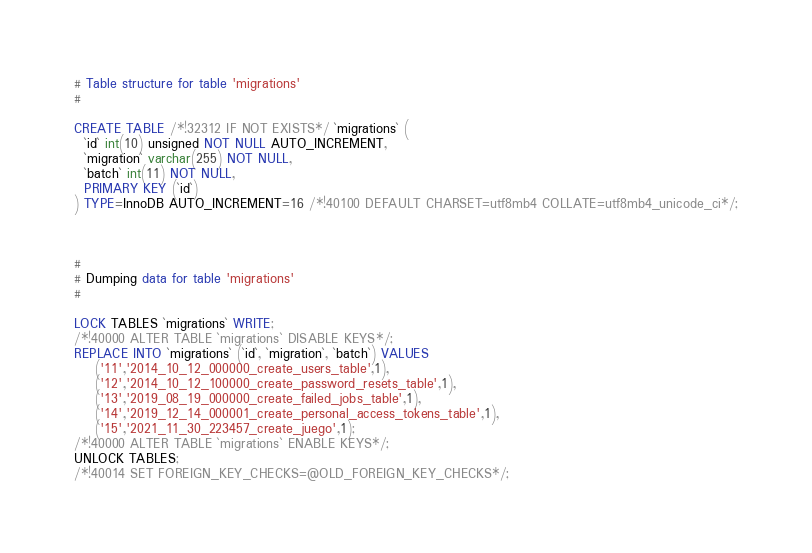<code> <loc_0><loc_0><loc_500><loc_500><_SQL_># Table structure for table 'migrations'
#

CREATE TABLE /*!32312 IF NOT EXISTS*/ `migrations` (
  `id` int(10) unsigned NOT NULL AUTO_INCREMENT,
  `migration` varchar(255) NOT NULL,
  `batch` int(11) NOT NULL,
  PRIMARY KEY (`id`)
) TYPE=InnoDB AUTO_INCREMENT=16 /*!40100 DEFAULT CHARSET=utf8mb4 COLLATE=utf8mb4_unicode_ci*/;



#
# Dumping data for table 'migrations'
#

LOCK TABLES `migrations` WRITE;
/*!40000 ALTER TABLE `migrations` DISABLE KEYS*/;
REPLACE INTO `migrations` (`id`, `migration`, `batch`) VALUES
	('11','2014_10_12_000000_create_users_table',1),
	('12','2014_10_12_100000_create_password_resets_table',1),
	('13','2019_08_19_000000_create_failed_jobs_table',1),
	('14','2019_12_14_000001_create_personal_access_tokens_table',1),
	('15','2021_11_30_223457_create_juego',1);
/*!40000 ALTER TABLE `migrations` ENABLE KEYS*/;
UNLOCK TABLES;
/*!40014 SET FOREIGN_KEY_CHECKS=@OLD_FOREIGN_KEY_CHECKS*/;
</code> 